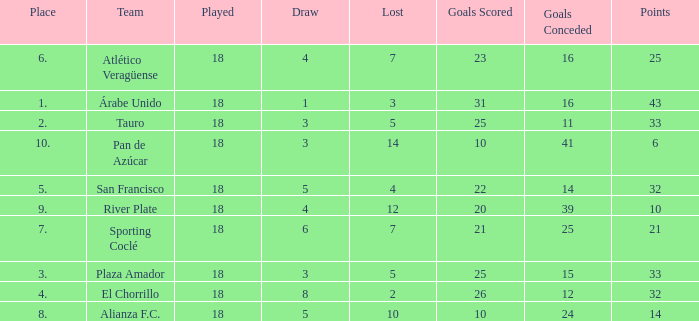How many points did the team have that conceded 41 goals and finish in a place larger than 10? 0.0. 